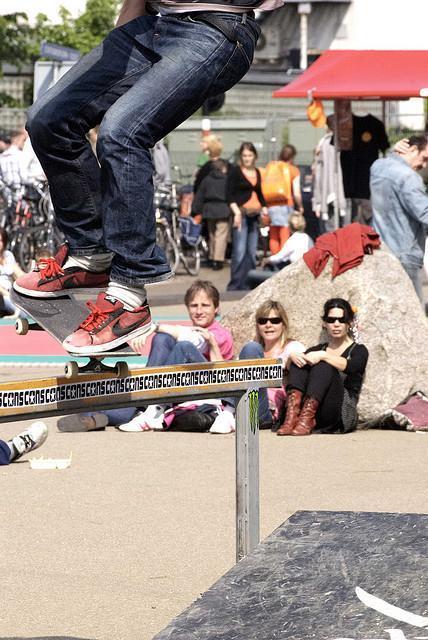How many people are in the picture?
Give a very brief answer. 9. How many ski poles are there?
Give a very brief answer. 0. 